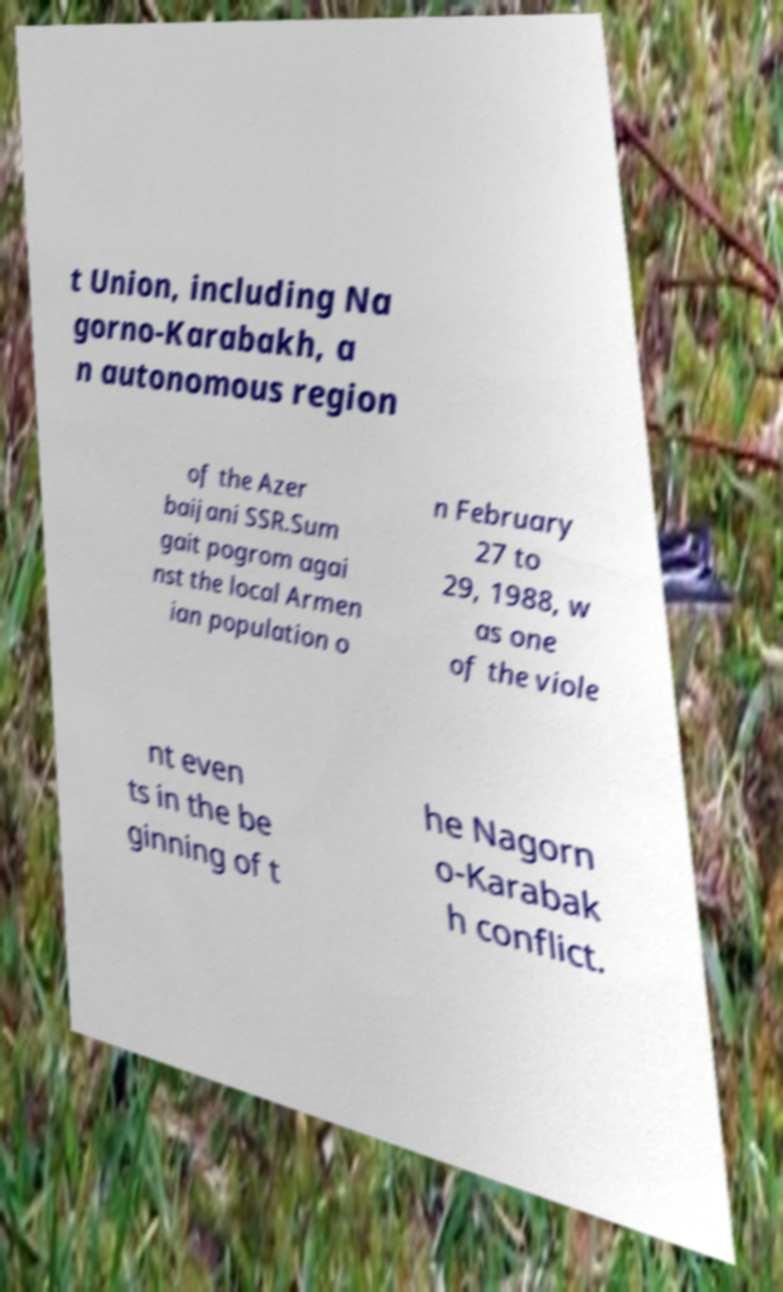Please identify and transcribe the text found in this image. t Union, including Na gorno-Karabakh, a n autonomous region of the Azer baijani SSR.Sum gait pogrom agai nst the local Armen ian population o n February 27 to 29, 1988, w as one of the viole nt even ts in the be ginning of t he Nagorn o-Karabak h conflict. 